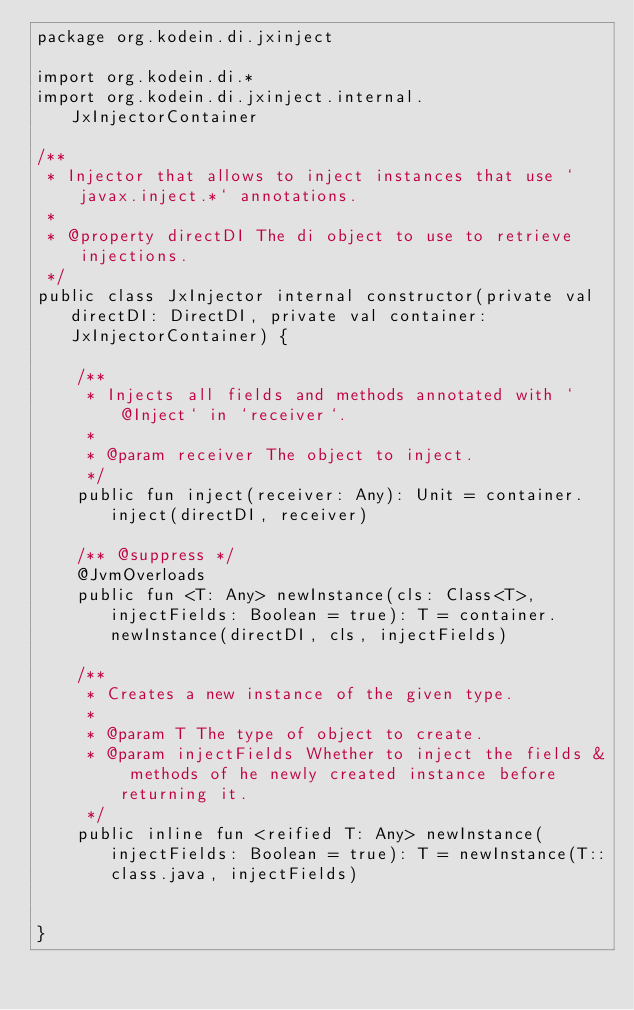Convert code to text. <code><loc_0><loc_0><loc_500><loc_500><_Kotlin_>package org.kodein.di.jxinject

import org.kodein.di.*
import org.kodein.di.jxinject.internal.JxInjectorContainer

/**
 * Injector that allows to inject instances that use `javax.inject.*` annotations.
 *
 * @property directDI The di object to use to retrieve injections.
 */
public class JxInjector internal constructor(private val directDI: DirectDI, private val container: JxInjectorContainer) {

    /**
     * Injects all fields and methods annotated with `@Inject` in `receiver`.
     *
     * @param receiver The object to inject.
     */
    public fun inject(receiver: Any): Unit = container.inject(directDI, receiver)

    /** @suppress */
    @JvmOverloads
    public fun <T: Any> newInstance(cls: Class<T>, injectFields: Boolean = true): T = container.newInstance(directDI, cls, injectFields)

    /**
     * Creates a new instance of the given type.
     *
     * @param T The type of object to create.
     * @param injectFields Whether to inject the fields & methods of he newly created instance before returning it.
     */
    public inline fun <reified T: Any> newInstance(injectFields: Boolean = true): T = newInstance(T::class.java, injectFields)


}
</code> 